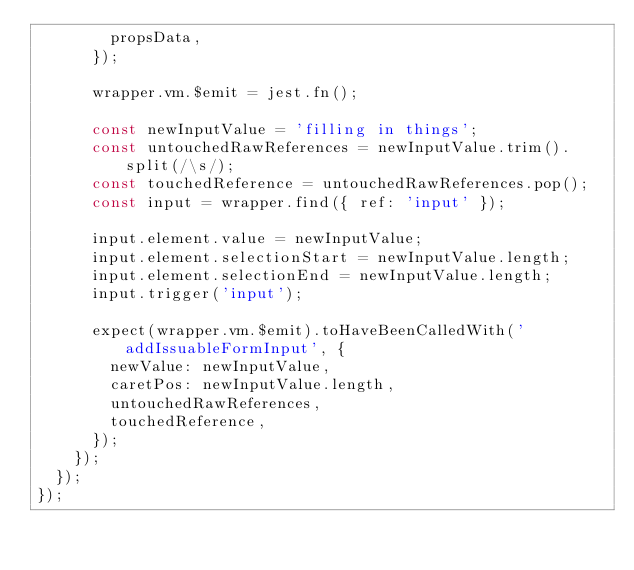Convert code to text. <code><loc_0><loc_0><loc_500><loc_500><_JavaScript_>        propsData,
      });

      wrapper.vm.$emit = jest.fn();

      const newInputValue = 'filling in things';
      const untouchedRawReferences = newInputValue.trim().split(/\s/);
      const touchedReference = untouchedRawReferences.pop();
      const input = wrapper.find({ ref: 'input' });

      input.element.value = newInputValue;
      input.element.selectionStart = newInputValue.length;
      input.element.selectionEnd = newInputValue.length;
      input.trigger('input');

      expect(wrapper.vm.$emit).toHaveBeenCalledWith('addIssuableFormInput', {
        newValue: newInputValue,
        caretPos: newInputValue.length,
        untouchedRawReferences,
        touchedReference,
      });
    });
  });
});
</code> 